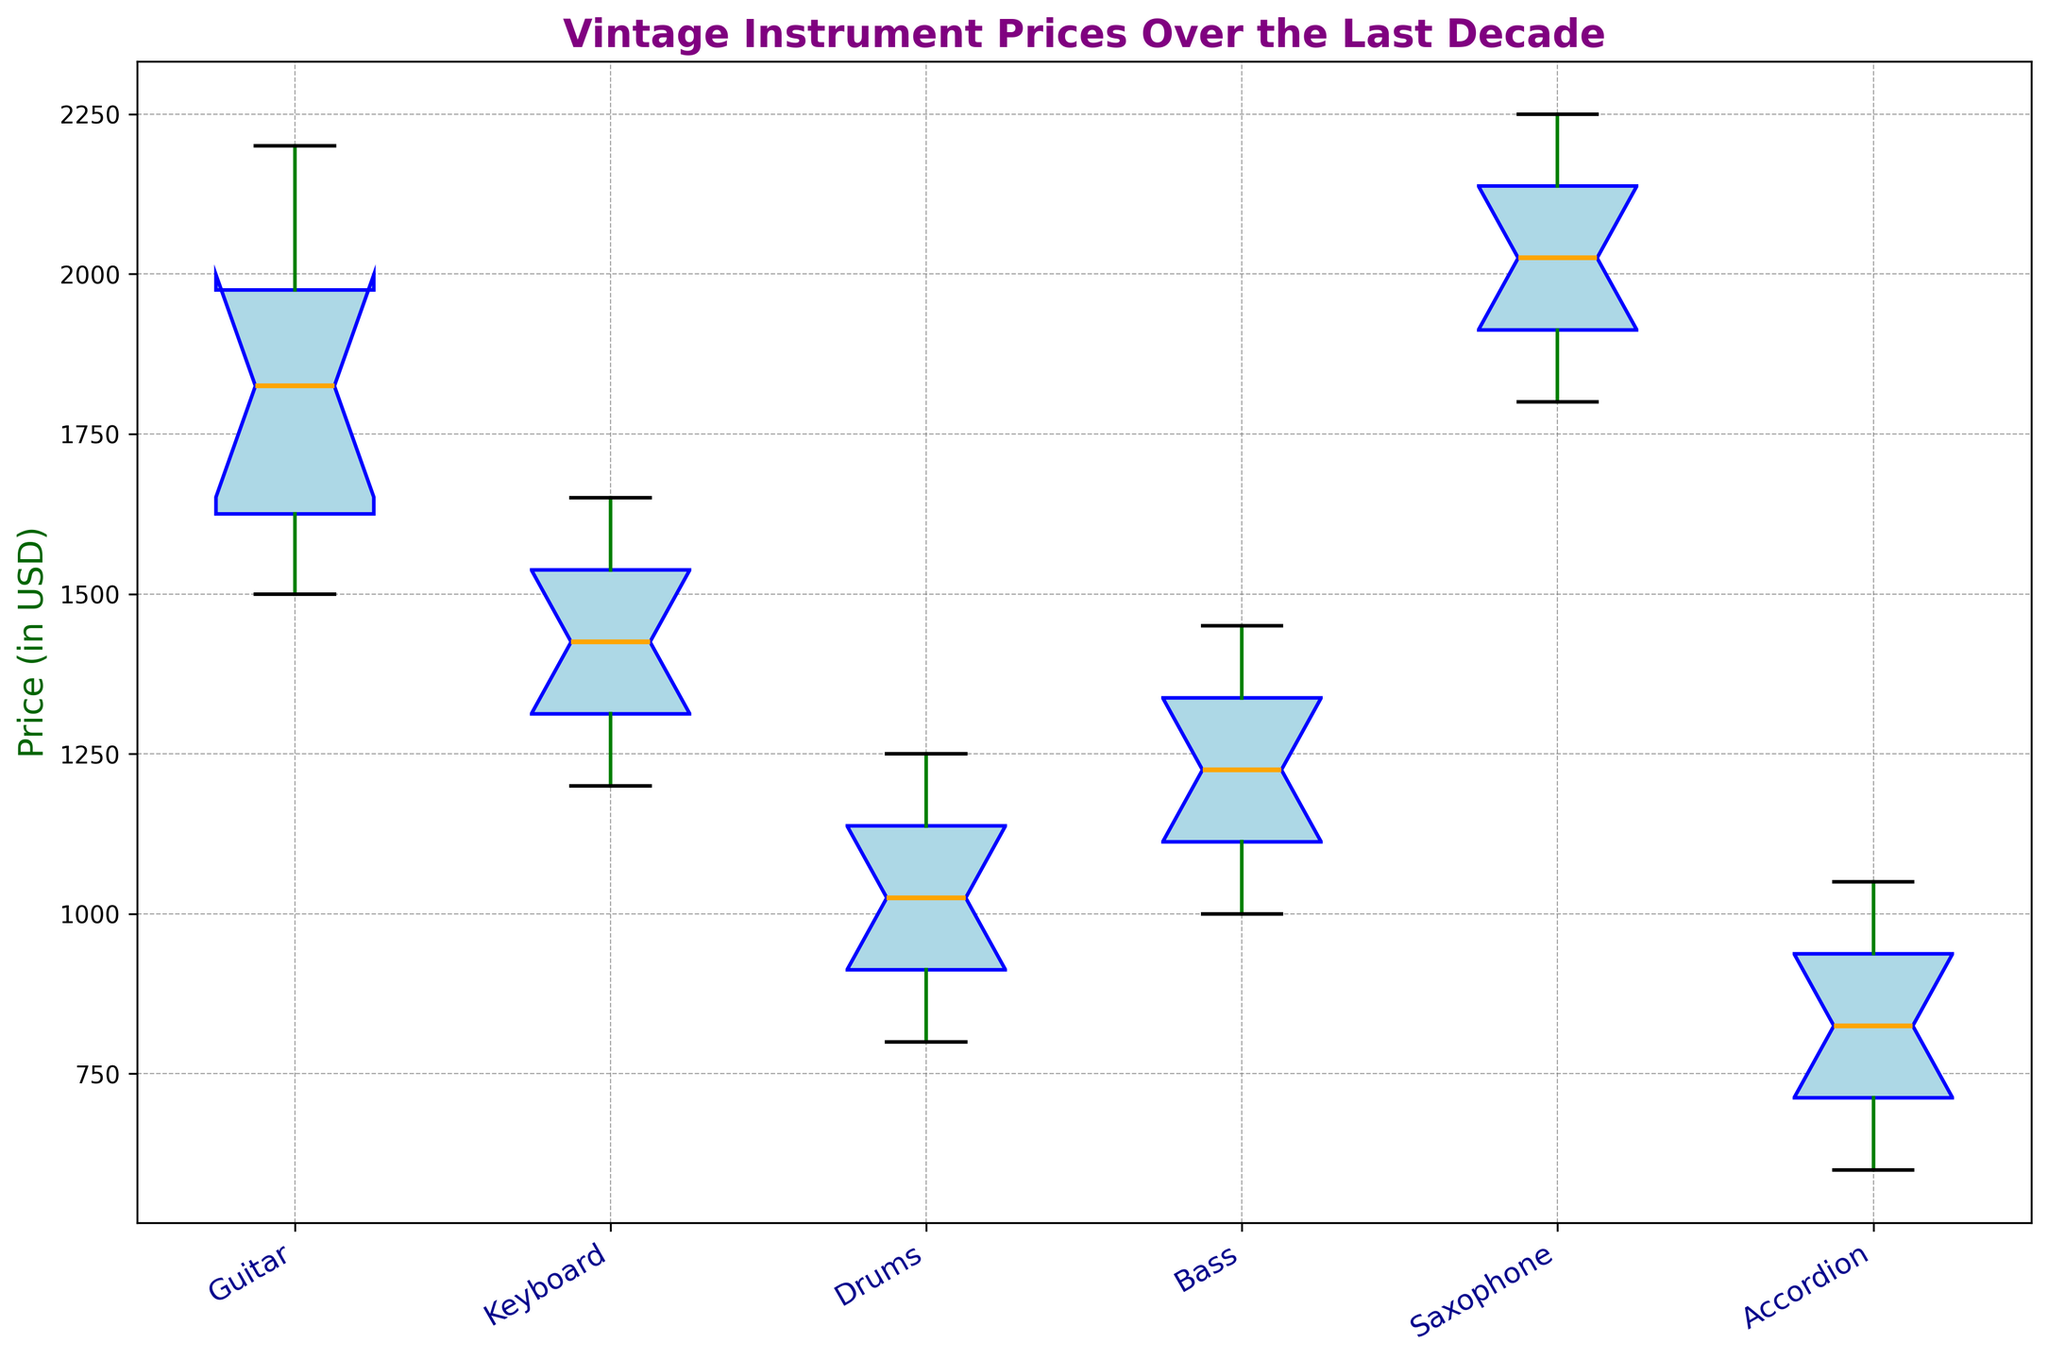Which instrument has the highest median price? Observe the notched boxplots for each instrument to identify which one has the highest median line (typically represented as a band). The saxophone has the highest median price when compared to other instruments.
Answer: Saxophone Which instrument type shows the widest range of prices? To determine the instrument with the widest price range, observe the length of the whiskers on the boxplots. The guitar has the widest range, with the whiskers extending the most.
Answer: Guitar Which instrument has the smallest interquartile range (IQR)? To find the smallest IQR, look for the box with the shortest height, which represents the distance between the first quartile (Q1) and the third quartile (Q3). The accordion has the smallest IQR.
Answer: Accordion Compare the median prices of guitars and keyboards. Which is higher, and by how much? Identify the median lines for guitars and keyboards. The guitar's median is higher than the keyboard's median. The median price for a guitar is around $1900 while for a keyboard, it is approximately $1450. Therefore, the guitar's median price is $450 higher.
Answer: Guitar is higher by $450 Between drums and bass, which instrument has a more consistent price (smaller variance) over the last decade? Consistency is reflected in the narrowness of the box and shorter whiskers. Compare the boxplots for drums and bass; the drums show smaller boxes and shorter whiskers, indicating less variance.
Answer: Drums What’s the price range of saxophones? The price range is given by the distance between the minimum and maximum whiskers. For saxophones, this range is between $1800 and $2250.
Answer: $1800 to $2250 Which instrument(s) have outliers in their price distribution? Outliers are generally indicated by distinct points outside the whiskers of the boxplots. Upon observing the figure, there are no explicit individual points outside the whiskers, indicating no outliers for any instrument.
Answer: None What is the difference between the maximum prices of guitars and accordions? Identify the top whiskers for both guitars and accordions. The maximum price for guitars is $2200 and for accordions is $1050. The difference is $2200 - $1050 = $1150.
Answer: $1150 What is the color of the boxes representing the price range for each instrument? Each instrument type's price range is shown with boxes that have a light blue color.
Answer: Light blue 